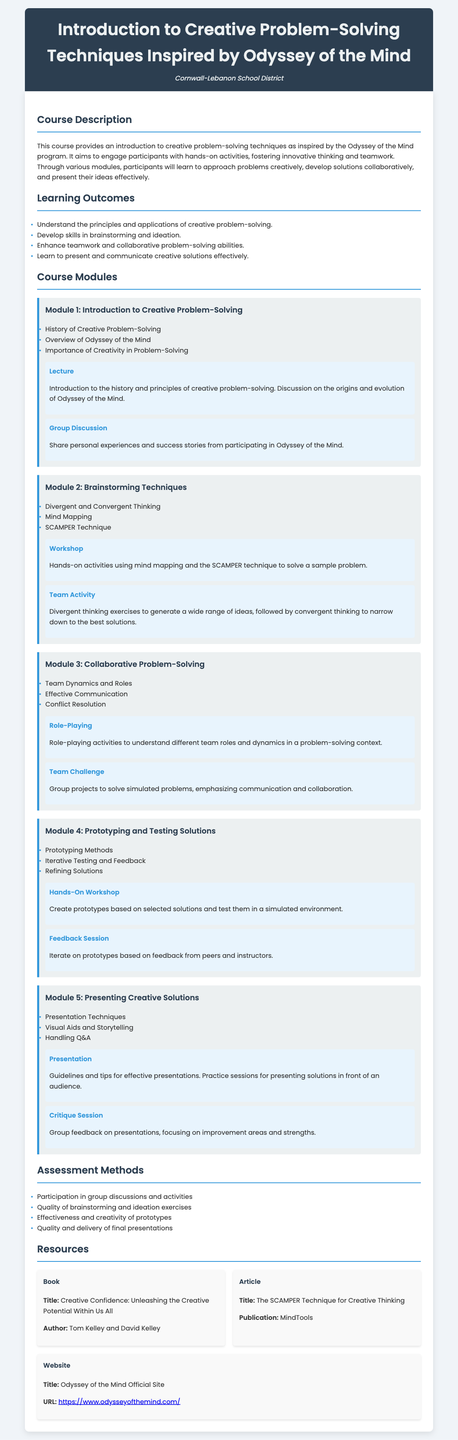What is the course title? The course title is explicitly stated at the top of the document in the header section.
Answer: Introduction to Creative Problem-Solving Techniques Inspired by Odyssey of the Mind What institution offers this course? The institution name is found below the course title in the header section.
Answer: Cornwall-Lebanon School District How many modules are there in the course? The total number of modules can be counted from the course modules section.
Answer: Five What is a resource discussed in the syllabus? Resources are listed in a dedicated section, highlighting books, articles, and websites.
Answer: Creative Confidence: Unleashing the Creative Potential Within Us All What is the main goal of the course? The main goal can be inferred from the course description section, which outlines the purpose of the course.
Answer: Engage participants with hands-on activities Which technique is mentioned under Module 2? The specific techniques are listed in a bullet point format within Module 2.
Answer: SCAMPER Technique What type of activity is included in Module 3? The activities for each module are described in detail, including types of activities.
Answer: Role-Playing What will be assessed in the course? Assessment methods are outlined in their own section, detailing what will be reviewed.
Answer: Participation in group discussions and activities What is one outcome participants will achieve? Learning outcomes are presented in a bullet point format that summarizes key skills participants can expect to gain.
Answer: Develop skills in brainstorming and ideation 